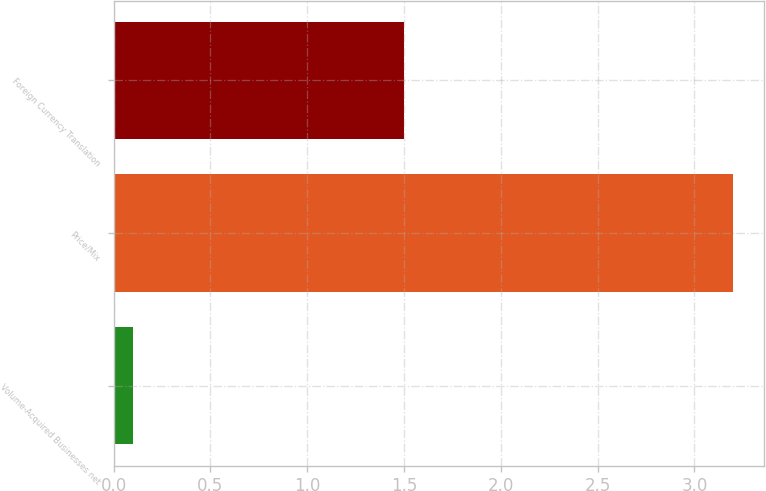Convert chart. <chart><loc_0><loc_0><loc_500><loc_500><bar_chart><fcel>Volume-Acquired Businesses net<fcel>Price/Mix<fcel>Foreign Currency Translation<nl><fcel>0.1<fcel>3.2<fcel>1.5<nl></chart> 